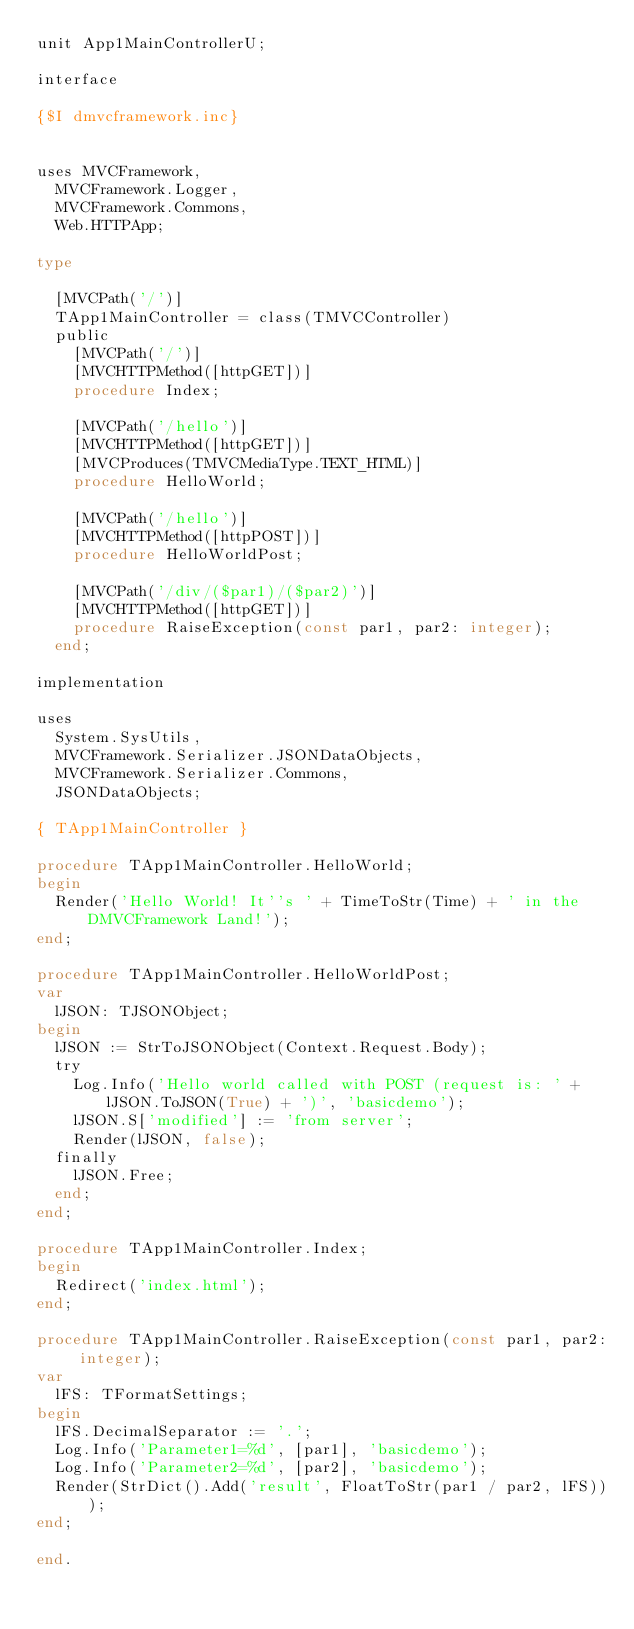<code> <loc_0><loc_0><loc_500><loc_500><_Pascal_>unit App1MainControllerU;

interface

{$I dmvcframework.inc}


uses MVCFramework,
  MVCFramework.Logger,
  MVCFramework.Commons,
  Web.HTTPApp;

type

  [MVCPath('/')]
  TApp1MainController = class(TMVCController)
  public
    [MVCPath('/')]
    [MVCHTTPMethod([httpGET])]
    procedure Index;

    [MVCPath('/hello')]
    [MVCHTTPMethod([httpGET])]
    [MVCProduces(TMVCMediaType.TEXT_HTML)]
    procedure HelloWorld;

    [MVCPath('/hello')]
    [MVCHTTPMethod([httpPOST])]
    procedure HelloWorldPost;

    [MVCPath('/div/($par1)/($par2)')]
    [MVCHTTPMethod([httpGET])]
    procedure RaiseException(const par1, par2: integer);
  end;

implementation

uses
  System.SysUtils,
  MVCFramework.Serializer.JSONDataObjects,
  MVCFramework.Serializer.Commons,
  JSONDataObjects;

{ TApp1MainController }

procedure TApp1MainController.HelloWorld;
begin
  Render('Hello World! It''s ' + TimeToStr(Time) + ' in the DMVCFramework Land!');
end;

procedure TApp1MainController.HelloWorldPost;
var
  lJSON: TJSONObject;
begin
  lJSON := StrToJSONObject(Context.Request.Body);
  try
    Log.Info('Hello world called with POST (request is: ' + lJSON.ToJSON(True) + ')', 'basicdemo');
    lJSON.S['modified'] := 'from server';
    Render(lJSON, false);
  finally
    lJSON.Free;
  end;
end;

procedure TApp1MainController.Index;
begin
  Redirect('index.html');
end;

procedure TApp1MainController.RaiseException(const par1, par2: integer);
var
  lFS: TFormatSettings;
begin
  lFS.DecimalSeparator := '.';
  Log.Info('Parameter1=%d', [par1], 'basicdemo');
  Log.Info('Parameter2=%d', [par2], 'basicdemo');
  Render(StrDict().Add('result', FloatToStr(par1 / par2, lFS)));
end;

end.
</code> 